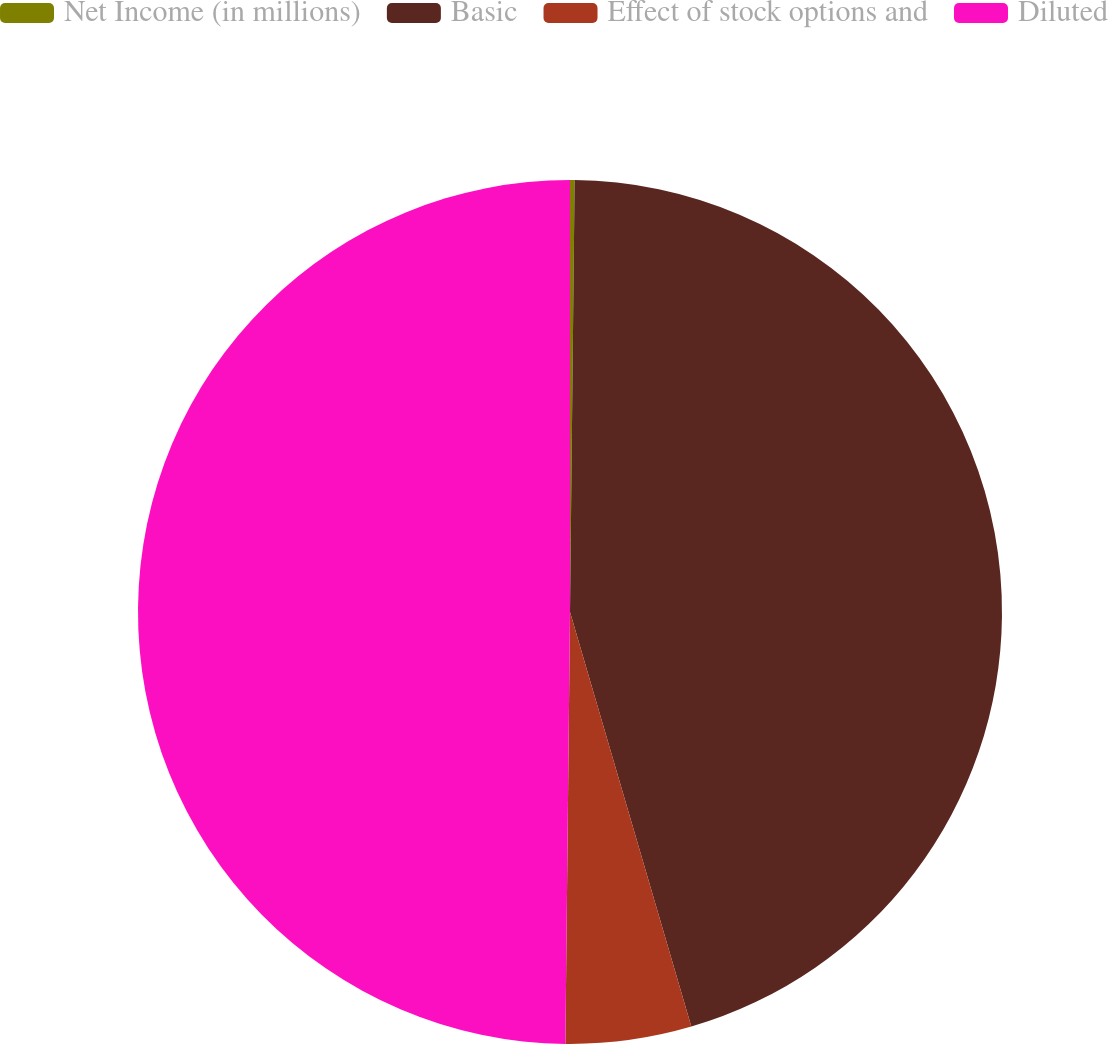Convert chart to OTSL. <chart><loc_0><loc_0><loc_500><loc_500><pie_chart><fcel>Net Income (in millions)<fcel>Basic<fcel>Effect of stock options and<fcel>Diluted<nl><fcel>0.17%<fcel>45.3%<fcel>4.7%<fcel>49.83%<nl></chart> 